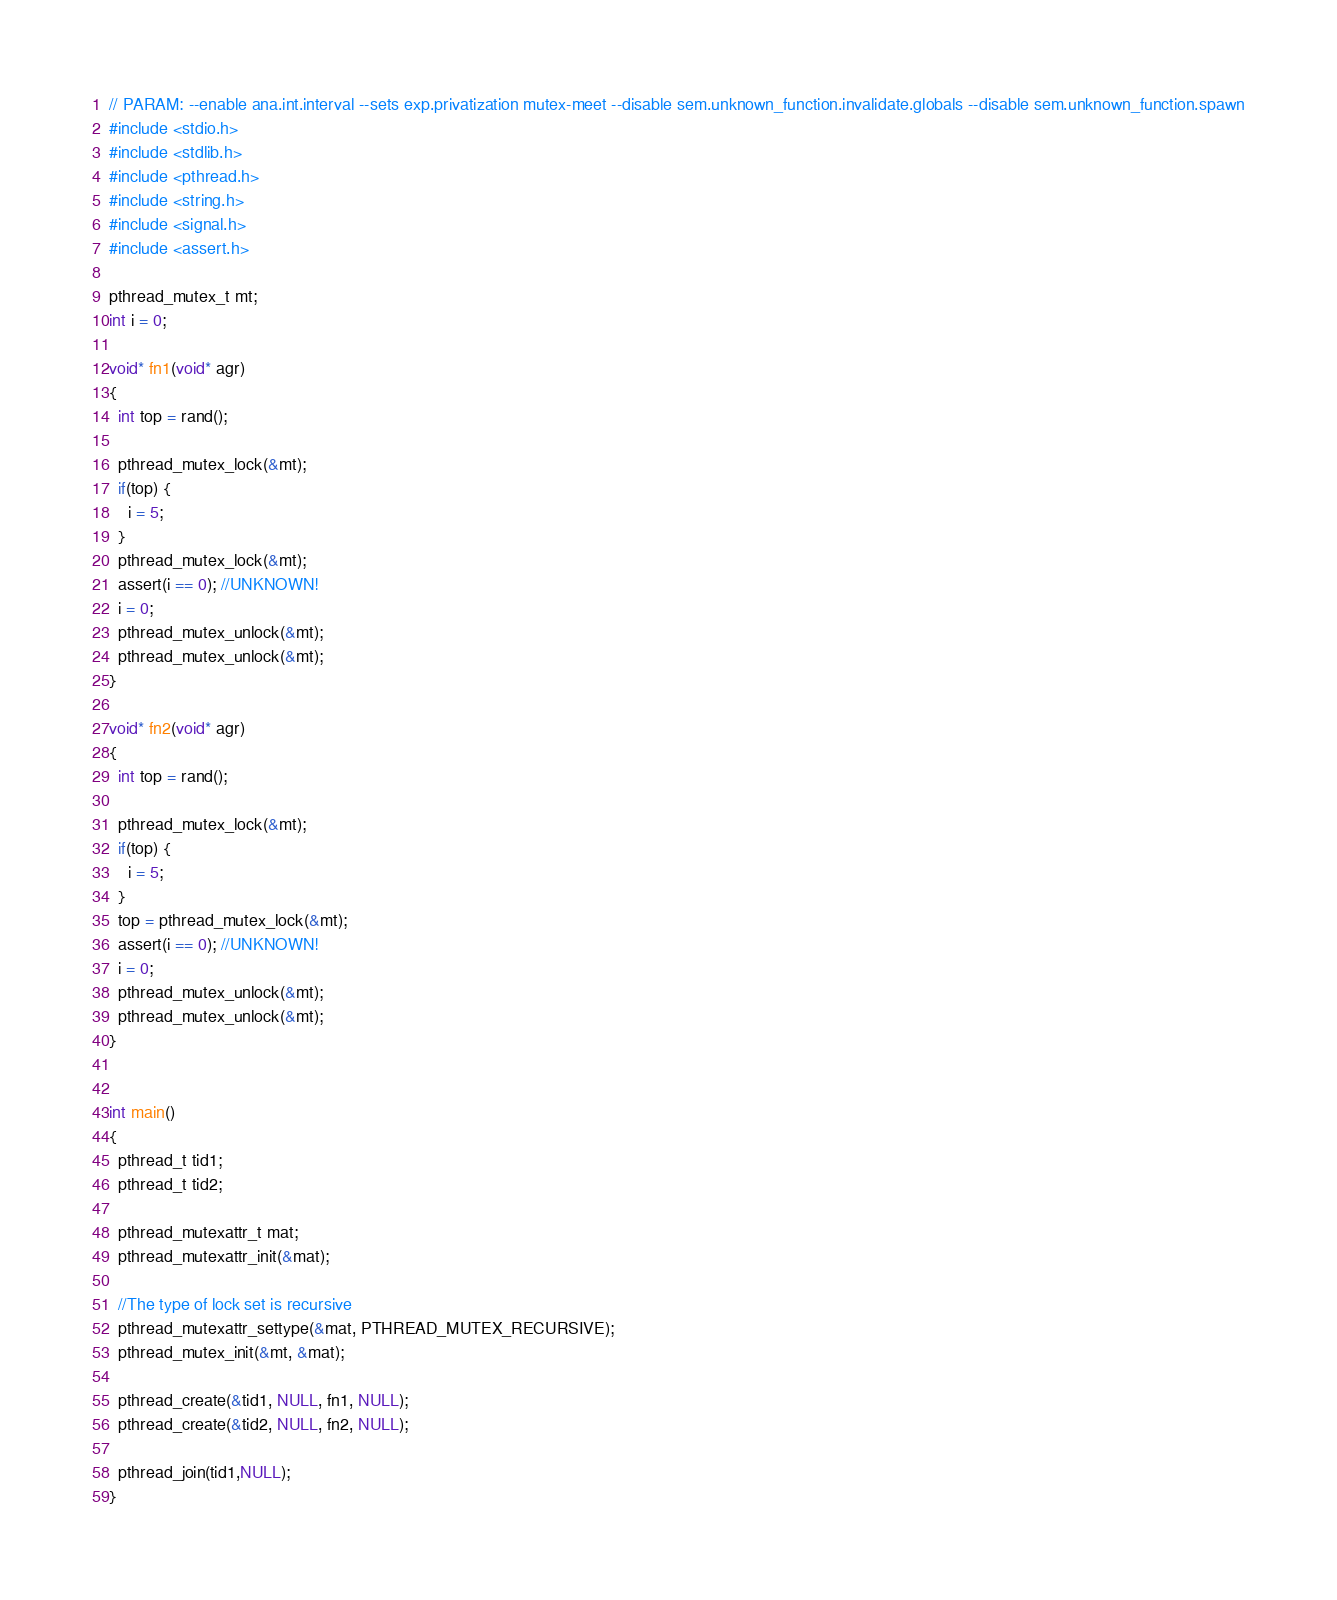<code> <loc_0><loc_0><loc_500><loc_500><_C_>// PARAM: --enable ana.int.interval --sets exp.privatization mutex-meet --disable sem.unknown_function.invalidate.globals --disable sem.unknown_function.spawn
#include <stdio.h>
#include <stdlib.h>
#include <pthread.h>
#include <string.h>
#include <signal.h>
#include <assert.h>

pthread_mutex_t mt;
int i = 0;

void* fn1(void* agr)
{
  int top = rand();

  pthread_mutex_lock(&mt);
  if(top) {
    i = 5;
  }
  pthread_mutex_lock(&mt);
  assert(i == 0); //UNKNOWN!
  i = 0;
  pthread_mutex_unlock(&mt);
  pthread_mutex_unlock(&mt);
}

void* fn2(void* agr)
{
  int top = rand();

  pthread_mutex_lock(&mt);
  if(top) {
    i = 5;
  }
  top = pthread_mutex_lock(&mt);
  assert(i == 0); //UNKNOWN!
  i = 0;
  pthread_mutex_unlock(&mt);
  pthread_mutex_unlock(&mt);
}


int main()
{
  pthread_t tid1;
  pthread_t tid2;

  pthread_mutexattr_t mat;
  pthread_mutexattr_init(&mat);

  //The type of lock set is recursive
  pthread_mutexattr_settype(&mat, PTHREAD_MUTEX_RECURSIVE);
  pthread_mutex_init(&mt, &mat);

  pthread_create(&tid1, NULL, fn1, NULL);
  pthread_create(&tid2, NULL, fn2, NULL);

  pthread_join(tid1,NULL);
}
</code> 